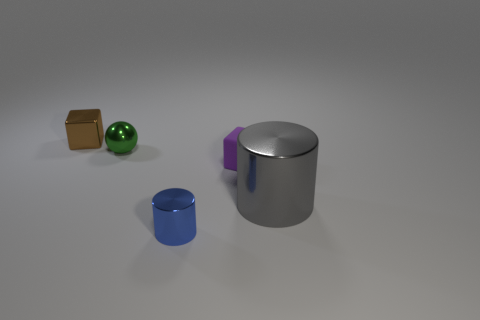Is there any other thing that is the same material as the small purple block?
Provide a short and direct response. No. Is the tiny matte object the same shape as the green metal thing?
Offer a terse response. No. Do the cube that is in front of the brown cube and the large gray metal thing have the same size?
Keep it short and to the point. No. There is a cylinder to the right of the cube on the right side of the small brown cube; how many small blue metallic objects are behind it?
Give a very brief answer. 0. What color is the block that is made of the same material as the gray cylinder?
Your response must be concise. Brown. Is there anything else that has the same size as the gray thing?
Offer a terse response. No. There is another metallic object that is the same shape as the purple object; what is its color?
Your answer should be very brief. Brown. What is the shape of the tiny thing right of the shiny cylinder that is on the left side of the cube that is in front of the tiny brown thing?
Your response must be concise. Cube. Are there fewer large objects that are on the left side of the small green object than tiny matte blocks in front of the brown metallic thing?
Give a very brief answer. Yes. Does the small cylinder have the same material as the tiny block that is behind the tiny green metal sphere?
Make the answer very short. Yes. 